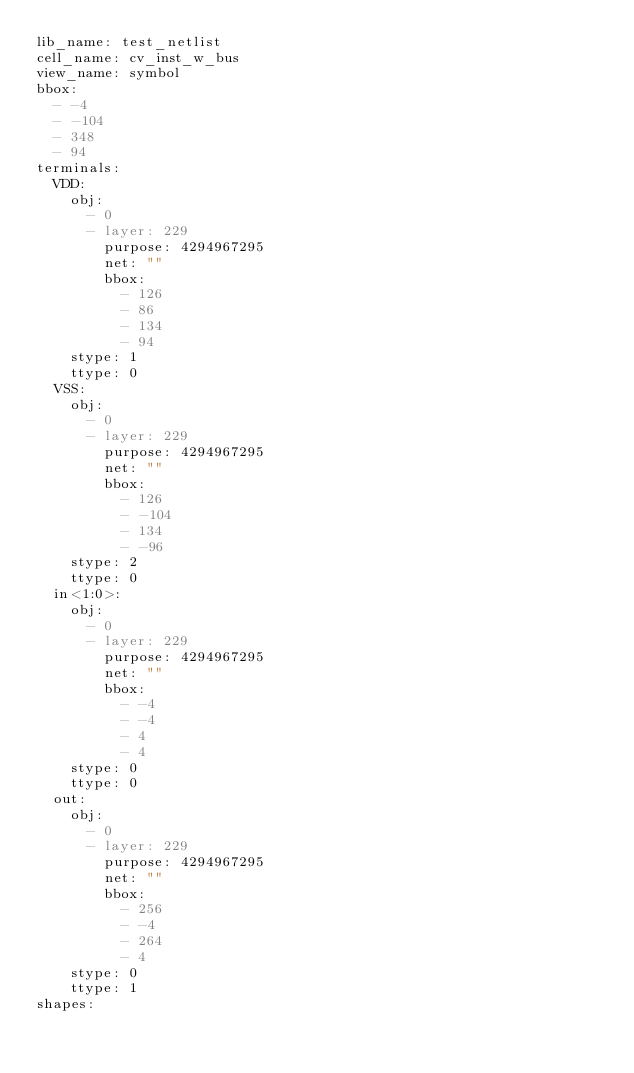<code> <loc_0><loc_0><loc_500><loc_500><_YAML_>lib_name: test_netlist
cell_name: cv_inst_w_bus
view_name: symbol
bbox:
  - -4
  - -104
  - 348
  - 94
terminals:
  VDD:
    obj:
      - 0
      - layer: 229
        purpose: 4294967295
        net: ""
        bbox:
          - 126
          - 86
          - 134
          - 94
    stype: 1
    ttype: 0
  VSS:
    obj:
      - 0
      - layer: 229
        purpose: 4294967295
        net: ""
        bbox:
          - 126
          - -104
          - 134
          - -96
    stype: 2
    ttype: 0
  in<1:0>:
    obj:
      - 0
      - layer: 229
        purpose: 4294967295
        net: ""
        bbox:
          - -4
          - -4
          - 4
          - 4
    stype: 0
    ttype: 0
  out:
    obj:
      - 0
      - layer: 229
        purpose: 4294967295
        net: ""
        bbox:
          - 256
          - -4
          - 264
          - 4
    stype: 0
    ttype: 1
shapes:</code> 